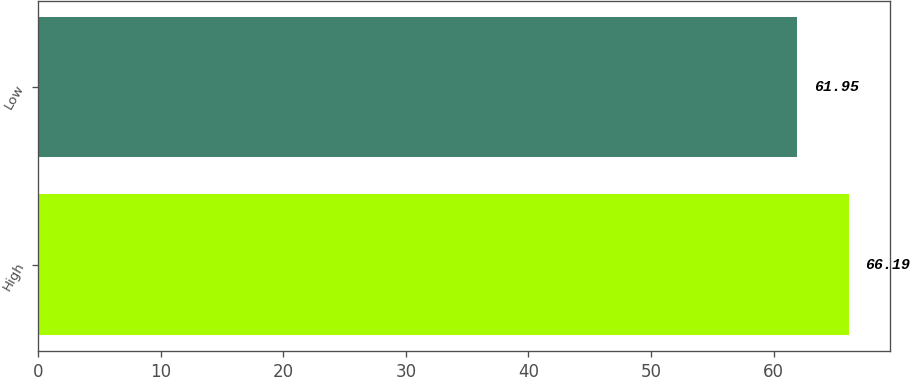Convert chart. <chart><loc_0><loc_0><loc_500><loc_500><bar_chart><fcel>High<fcel>Low<nl><fcel>66.19<fcel>61.95<nl></chart> 